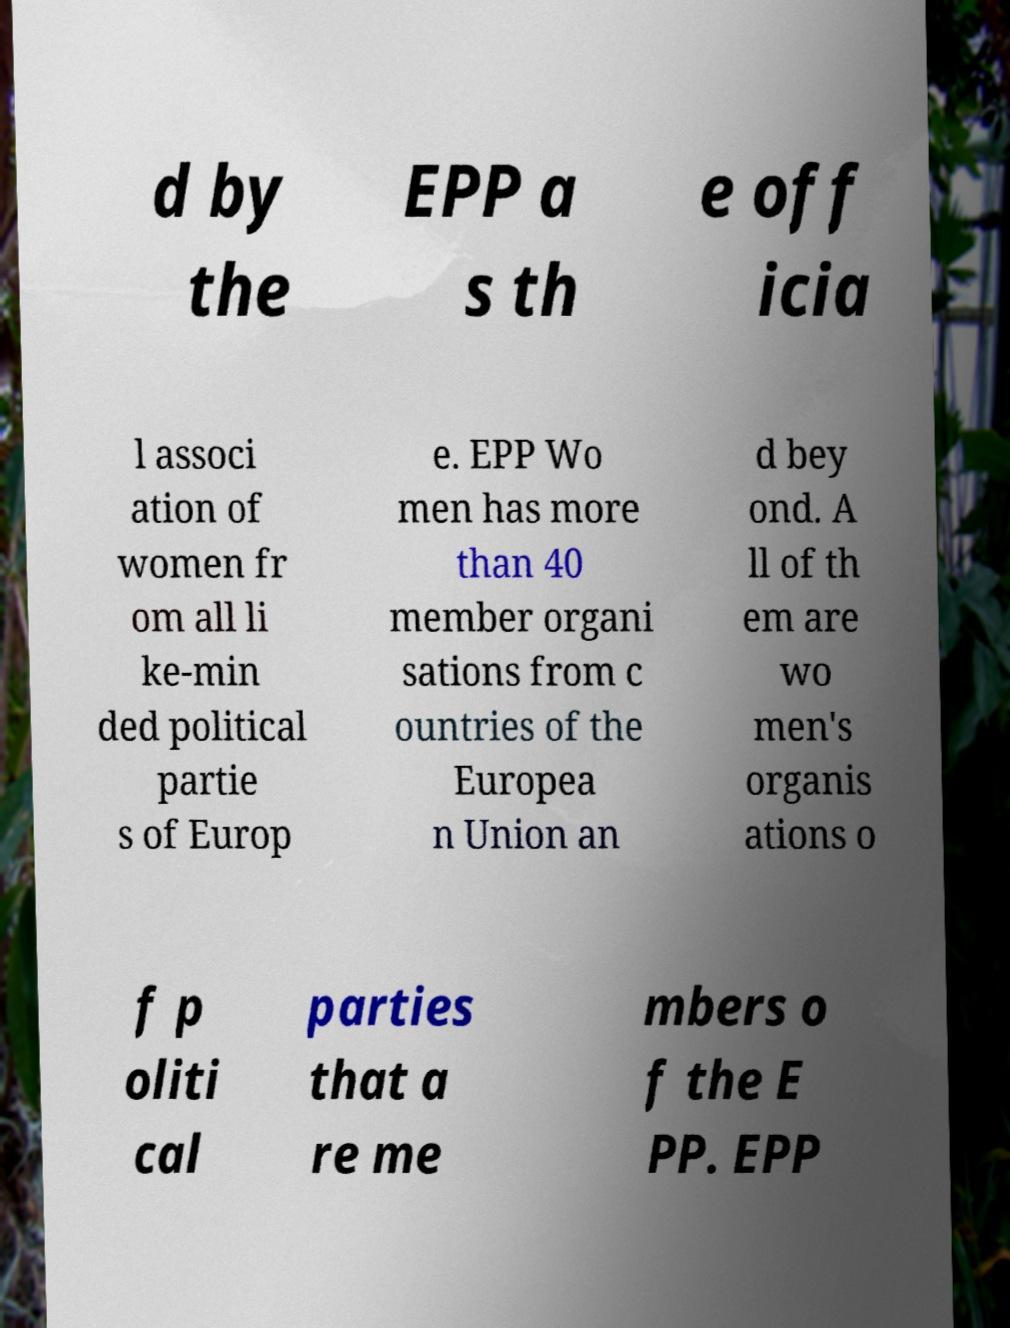There's text embedded in this image that I need extracted. Can you transcribe it verbatim? d by the EPP a s th e off icia l associ ation of women fr om all li ke-min ded political partie s of Europ e. EPP Wo men has more than 40 member organi sations from c ountries of the Europea n Union an d bey ond. A ll of th em are wo men's organis ations o f p oliti cal parties that a re me mbers o f the E PP. EPP 